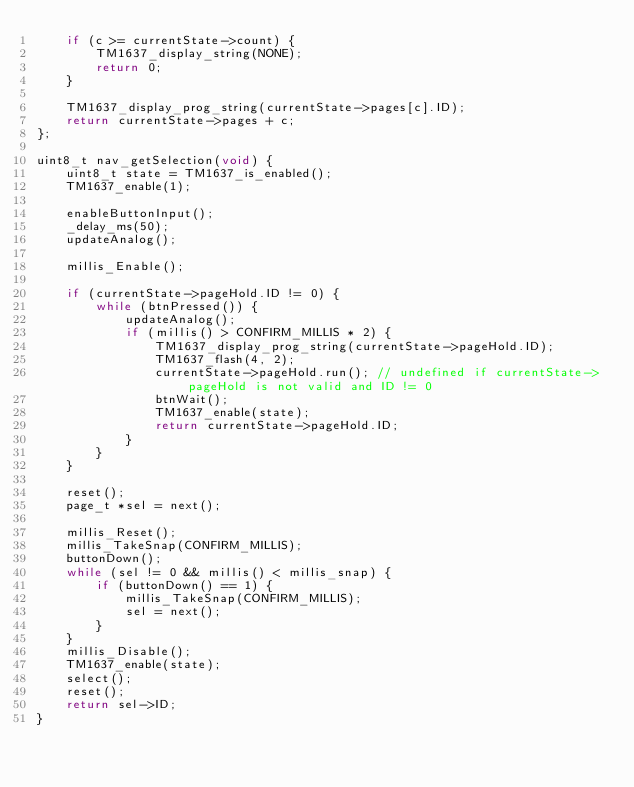<code> <loc_0><loc_0><loc_500><loc_500><_C_>    if (c >= currentState->count) {
        TM1637_display_string(NONE);
        return 0;
    }

    TM1637_display_prog_string(currentState->pages[c].ID);
    return currentState->pages + c;
};

uint8_t nav_getSelection(void) {
    uint8_t state = TM1637_is_enabled();
    TM1637_enable(1);

    enableButtonInput();
    _delay_ms(50);
    updateAnalog();

    millis_Enable();

    if (currentState->pageHold.ID != 0) {
        while (btnPressed()) {
            updateAnalog();
            if (millis() > CONFIRM_MILLIS * 2) {
                TM1637_display_prog_string(currentState->pageHold.ID);
                TM1637_flash(4, 2);
                currentState->pageHold.run(); // undefined if currentState->pageHold is not valid and ID != 0
                btnWait();
                TM1637_enable(state);
                return currentState->pageHold.ID;
            }
        }
    }

    reset();
    page_t *sel = next();

    millis_Reset();
    millis_TakeSnap(CONFIRM_MILLIS);
    buttonDown();
    while (sel != 0 && millis() < millis_snap) {
        if (buttonDown() == 1) {
            millis_TakeSnap(CONFIRM_MILLIS);
            sel = next();
        }
    }
    millis_Disable();
    TM1637_enable(state);
    select();
    reset();
    return sel->ID;
}</code> 